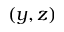Convert formula to latex. <formula><loc_0><loc_0><loc_500><loc_500>( y , z )</formula> 